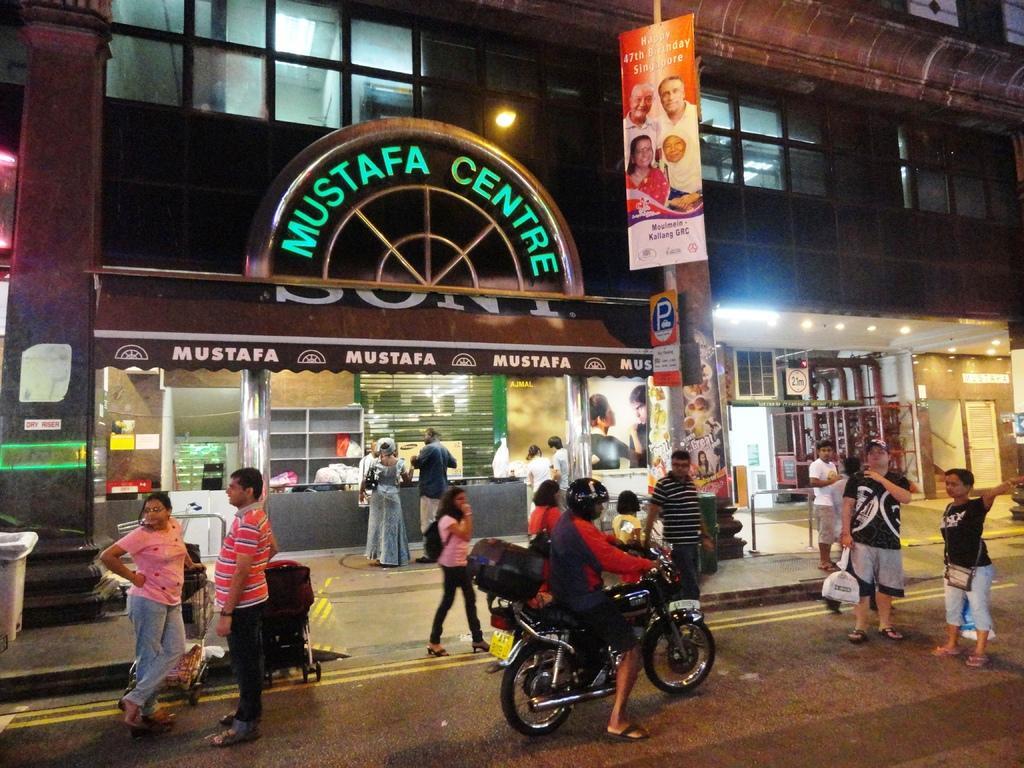Can you describe this image briefly? In this we can see group of persons standing on the ground. one person wearing a helmet is riding motorcycle. One girl is carrying a bag. In the background, we can see a group of poles, building with a sign board and some text on it. A poster with group of persons and some lights. 